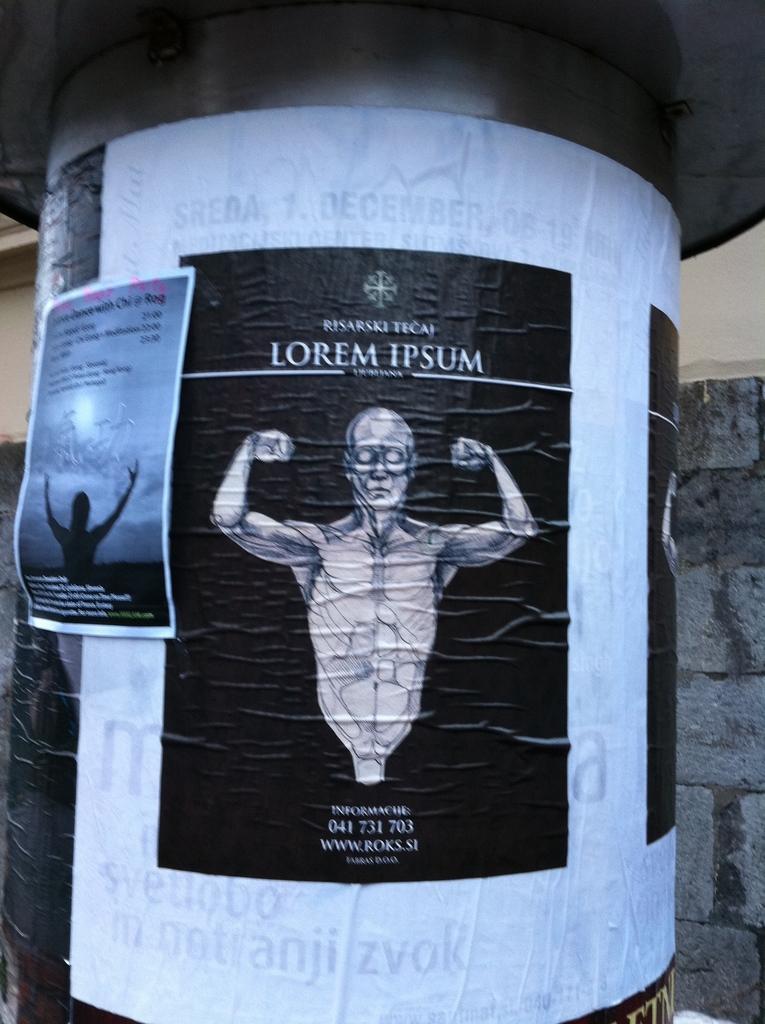How would you summarize this image in a sentence or two? In this picture we can see a pillar, on this pillar we can see posters and we can see a wall in the background. 